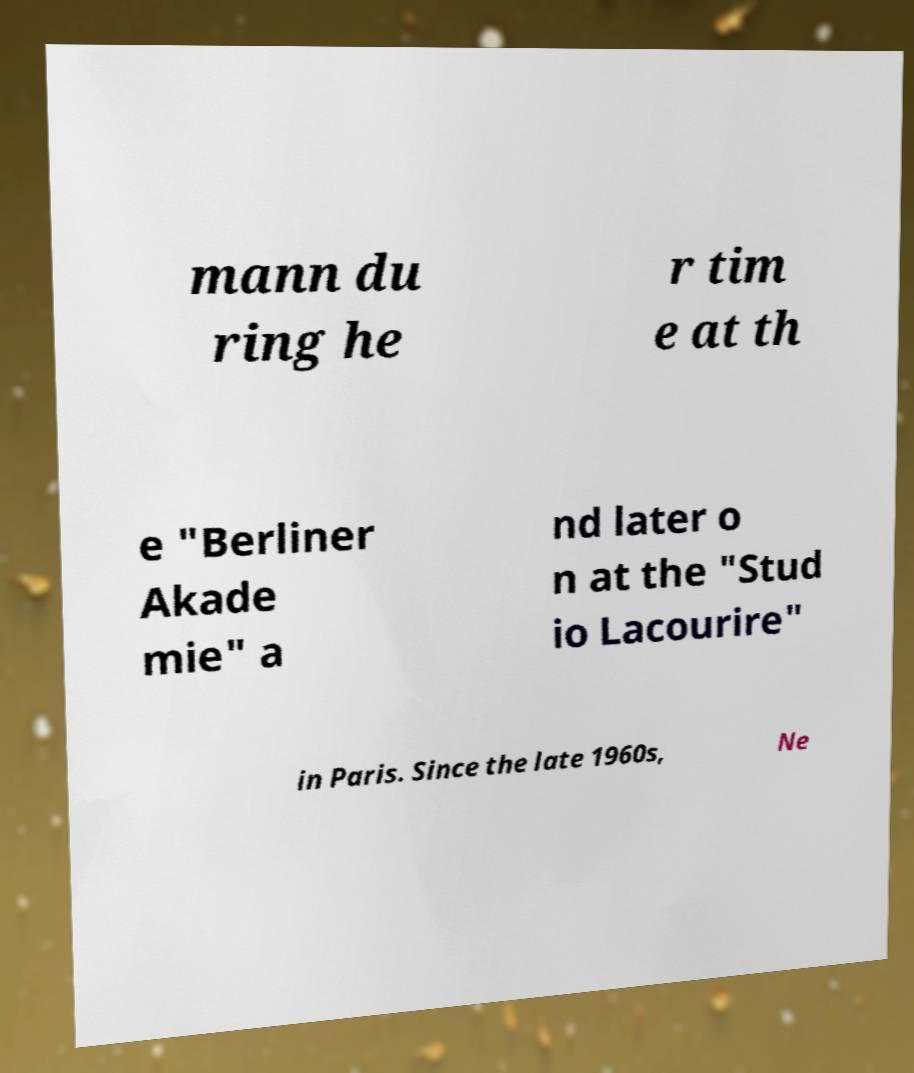There's text embedded in this image that I need extracted. Can you transcribe it verbatim? mann du ring he r tim e at th e "Berliner Akade mie" a nd later o n at the "Stud io Lacourire" in Paris. Since the late 1960s, Ne 